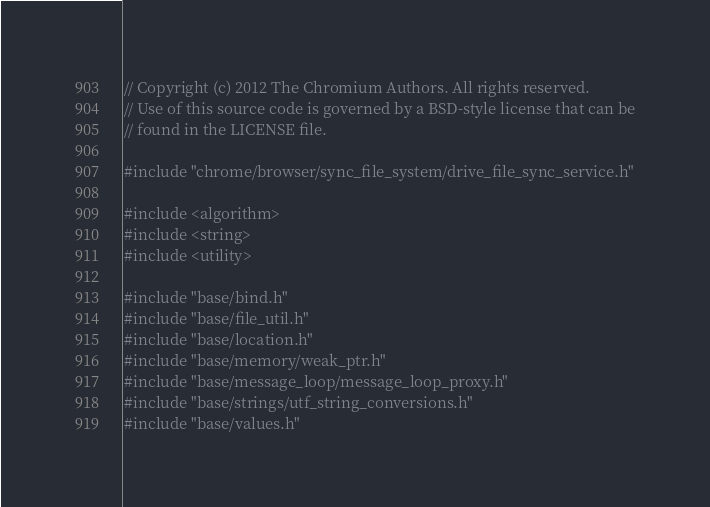<code> <loc_0><loc_0><loc_500><loc_500><_C++_>// Copyright (c) 2012 The Chromium Authors. All rights reserved.
// Use of this source code is governed by a BSD-style license that can be
// found in the LICENSE file.

#include "chrome/browser/sync_file_system/drive_file_sync_service.h"

#include <algorithm>
#include <string>
#include <utility>

#include "base/bind.h"
#include "base/file_util.h"
#include "base/location.h"
#include "base/memory/weak_ptr.h"
#include "base/message_loop/message_loop_proxy.h"
#include "base/strings/utf_string_conversions.h"
#include "base/values.h"</code> 